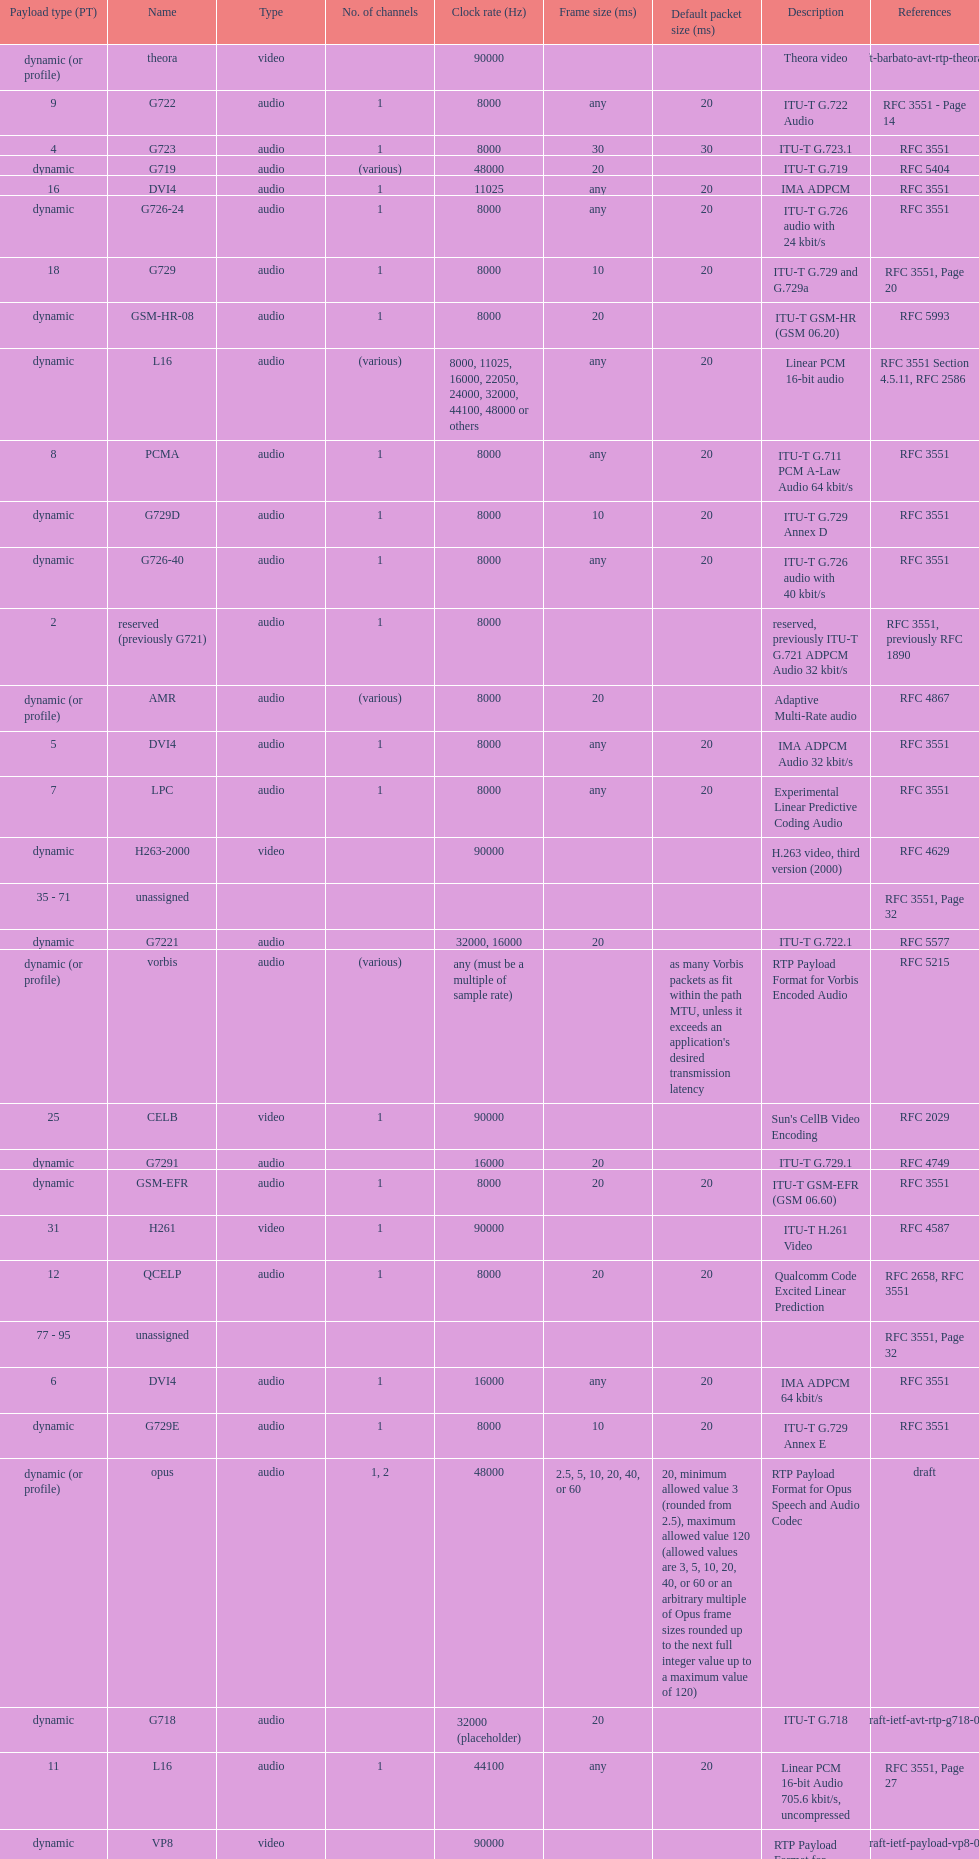What is the average number of channels? 1. 